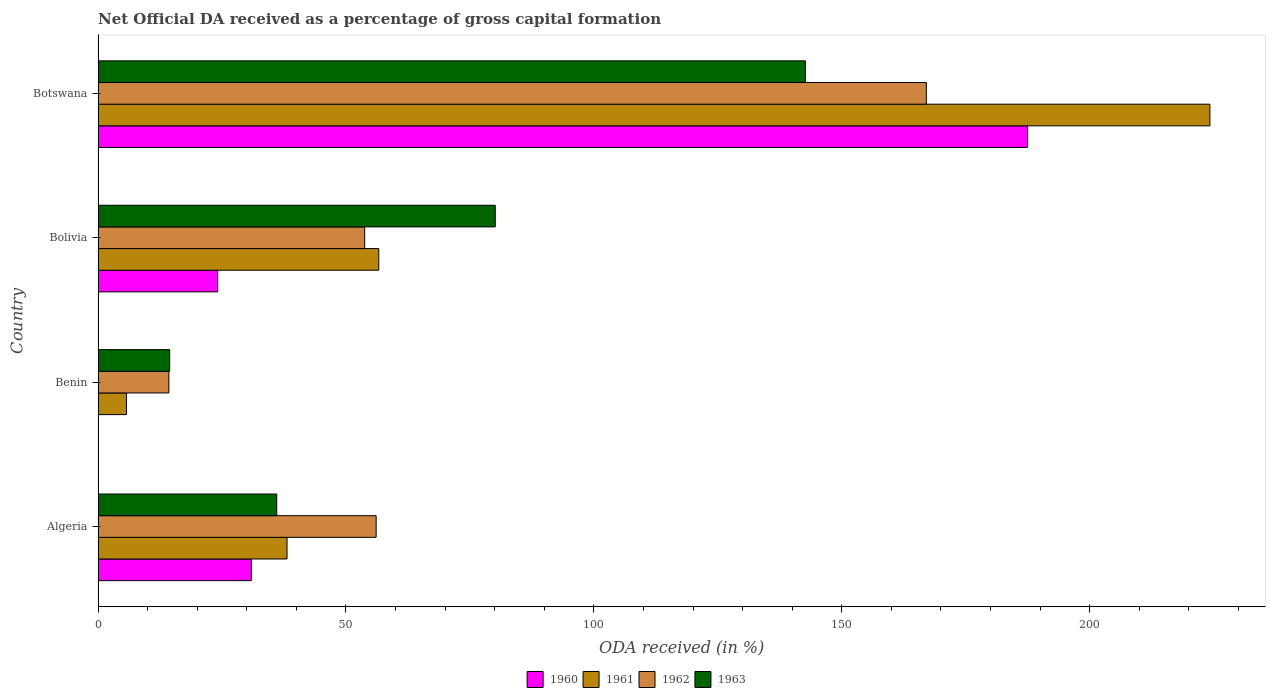How many different coloured bars are there?
Provide a short and direct response. 4. How many bars are there on the 2nd tick from the top?
Your response must be concise. 4. What is the label of the 3rd group of bars from the top?
Offer a very short reply. Benin. In how many cases, is the number of bars for a given country not equal to the number of legend labels?
Ensure brevity in your answer.  0. What is the net ODA received in 1963 in Botswana?
Your answer should be compact. 142.68. Across all countries, what is the maximum net ODA received in 1962?
Your answer should be compact. 167.07. Across all countries, what is the minimum net ODA received in 1963?
Give a very brief answer. 14.44. In which country was the net ODA received in 1961 maximum?
Offer a terse response. Botswana. In which country was the net ODA received in 1963 minimum?
Provide a succinct answer. Benin. What is the total net ODA received in 1961 in the graph?
Keep it short and to the point. 324.72. What is the difference between the net ODA received in 1960 in Benin and that in Bolivia?
Provide a succinct answer. -24.04. What is the difference between the net ODA received in 1962 in Botswana and the net ODA received in 1963 in Benin?
Provide a short and direct response. 152.63. What is the average net ODA received in 1962 per country?
Provide a short and direct response. 72.8. What is the difference between the net ODA received in 1962 and net ODA received in 1960 in Algeria?
Your answer should be very brief. 25.19. In how many countries, is the net ODA received in 1963 greater than 220 %?
Your answer should be very brief. 0. What is the ratio of the net ODA received in 1963 in Benin to that in Botswana?
Provide a short and direct response. 0.1. Is the net ODA received in 1962 in Benin less than that in Bolivia?
Ensure brevity in your answer.  Yes. Is the difference between the net ODA received in 1962 in Benin and Botswana greater than the difference between the net ODA received in 1960 in Benin and Botswana?
Offer a very short reply. Yes. What is the difference between the highest and the second highest net ODA received in 1963?
Give a very brief answer. 62.56. What is the difference between the highest and the lowest net ODA received in 1962?
Ensure brevity in your answer.  152.79. In how many countries, is the net ODA received in 1963 greater than the average net ODA received in 1963 taken over all countries?
Provide a succinct answer. 2. Is it the case that in every country, the sum of the net ODA received in 1960 and net ODA received in 1961 is greater than the sum of net ODA received in 1963 and net ODA received in 1962?
Your answer should be compact. No. What does the 3rd bar from the top in Botswana represents?
Ensure brevity in your answer.  1961. What does the 1st bar from the bottom in Botswana represents?
Your answer should be very brief. 1960. Is it the case that in every country, the sum of the net ODA received in 1963 and net ODA received in 1961 is greater than the net ODA received in 1962?
Your response must be concise. Yes. How many bars are there?
Give a very brief answer. 16. Are all the bars in the graph horizontal?
Offer a very short reply. Yes. How many countries are there in the graph?
Give a very brief answer. 4. Does the graph contain any zero values?
Make the answer very short. No. Where does the legend appear in the graph?
Give a very brief answer. Bottom center. How are the legend labels stacked?
Offer a very short reply. Horizontal. What is the title of the graph?
Offer a terse response. Net Official DA received as a percentage of gross capital formation. Does "1974" appear as one of the legend labels in the graph?
Your answer should be compact. No. What is the label or title of the X-axis?
Offer a very short reply. ODA received (in %). What is the label or title of the Y-axis?
Provide a short and direct response. Country. What is the ODA received (in %) in 1960 in Algeria?
Offer a terse response. 30.9. What is the ODA received (in %) of 1961 in Algeria?
Offer a terse response. 38.11. What is the ODA received (in %) of 1962 in Algeria?
Give a very brief answer. 56.09. What is the ODA received (in %) of 1963 in Algeria?
Offer a terse response. 36.04. What is the ODA received (in %) of 1960 in Benin?
Ensure brevity in your answer.  0.08. What is the ODA received (in %) of 1961 in Benin?
Give a very brief answer. 5.73. What is the ODA received (in %) of 1962 in Benin?
Provide a short and direct response. 14.28. What is the ODA received (in %) of 1963 in Benin?
Provide a short and direct response. 14.44. What is the ODA received (in %) in 1960 in Bolivia?
Ensure brevity in your answer.  24.12. What is the ODA received (in %) in 1961 in Bolivia?
Your response must be concise. 56.62. What is the ODA received (in %) in 1962 in Bolivia?
Keep it short and to the point. 53.77. What is the ODA received (in %) in 1963 in Bolivia?
Offer a terse response. 80.11. What is the ODA received (in %) in 1960 in Botswana?
Provide a short and direct response. 187.49. What is the ODA received (in %) of 1961 in Botswana?
Provide a short and direct response. 224.27. What is the ODA received (in %) in 1962 in Botswana?
Offer a very short reply. 167.07. What is the ODA received (in %) of 1963 in Botswana?
Ensure brevity in your answer.  142.68. Across all countries, what is the maximum ODA received (in %) in 1960?
Keep it short and to the point. 187.49. Across all countries, what is the maximum ODA received (in %) in 1961?
Keep it short and to the point. 224.27. Across all countries, what is the maximum ODA received (in %) of 1962?
Your response must be concise. 167.07. Across all countries, what is the maximum ODA received (in %) of 1963?
Give a very brief answer. 142.68. Across all countries, what is the minimum ODA received (in %) of 1960?
Your answer should be compact. 0.08. Across all countries, what is the minimum ODA received (in %) of 1961?
Offer a very short reply. 5.73. Across all countries, what is the minimum ODA received (in %) in 1962?
Offer a terse response. 14.28. Across all countries, what is the minimum ODA received (in %) in 1963?
Provide a succinct answer. 14.44. What is the total ODA received (in %) in 1960 in the graph?
Offer a terse response. 242.58. What is the total ODA received (in %) in 1961 in the graph?
Give a very brief answer. 324.72. What is the total ODA received (in %) of 1962 in the graph?
Provide a succinct answer. 291.21. What is the total ODA received (in %) in 1963 in the graph?
Your response must be concise. 273.27. What is the difference between the ODA received (in %) of 1960 in Algeria and that in Benin?
Your answer should be compact. 30.82. What is the difference between the ODA received (in %) in 1961 in Algeria and that in Benin?
Your response must be concise. 32.39. What is the difference between the ODA received (in %) in 1962 in Algeria and that in Benin?
Your response must be concise. 41.81. What is the difference between the ODA received (in %) of 1963 in Algeria and that in Benin?
Keep it short and to the point. 21.6. What is the difference between the ODA received (in %) of 1960 in Algeria and that in Bolivia?
Your response must be concise. 6.78. What is the difference between the ODA received (in %) of 1961 in Algeria and that in Bolivia?
Your response must be concise. -18.5. What is the difference between the ODA received (in %) of 1962 in Algeria and that in Bolivia?
Offer a terse response. 2.31. What is the difference between the ODA received (in %) of 1963 in Algeria and that in Bolivia?
Provide a short and direct response. -44.08. What is the difference between the ODA received (in %) of 1960 in Algeria and that in Botswana?
Ensure brevity in your answer.  -156.58. What is the difference between the ODA received (in %) in 1961 in Algeria and that in Botswana?
Provide a short and direct response. -186.15. What is the difference between the ODA received (in %) of 1962 in Algeria and that in Botswana?
Your answer should be compact. -110.98. What is the difference between the ODA received (in %) in 1963 in Algeria and that in Botswana?
Your answer should be very brief. -106.64. What is the difference between the ODA received (in %) of 1960 in Benin and that in Bolivia?
Offer a terse response. -24.04. What is the difference between the ODA received (in %) of 1961 in Benin and that in Bolivia?
Provide a short and direct response. -50.89. What is the difference between the ODA received (in %) of 1962 in Benin and that in Bolivia?
Your response must be concise. -39.5. What is the difference between the ODA received (in %) of 1963 in Benin and that in Bolivia?
Your response must be concise. -65.67. What is the difference between the ODA received (in %) in 1960 in Benin and that in Botswana?
Give a very brief answer. -187.41. What is the difference between the ODA received (in %) of 1961 in Benin and that in Botswana?
Your response must be concise. -218.54. What is the difference between the ODA received (in %) of 1962 in Benin and that in Botswana?
Your answer should be compact. -152.79. What is the difference between the ODA received (in %) of 1963 in Benin and that in Botswana?
Provide a short and direct response. -128.24. What is the difference between the ODA received (in %) in 1960 in Bolivia and that in Botswana?
Offer a very short reply. -163.37. What is the difference between the ODA received (in %) of 1961 in Bolivia and that in Botswana?
Ensure brevity in your answer.  -167.65. What is the difference between the ODA received (in %) in 1962 in Bolivia and that in Botswana?
Make the answer very short. -113.3. What is the difference between the ODA received (in %) of 1963 in Bolivia and that in Botswana?
Offer a terse response. -62.56. What is the difference between the ODA received (in %) in 1960 in Algeria and the ODA received (in %) in 1961 in Benin?
Your response must be concise. 25.17. What is the difference between the ODA received (in %) of 1960 in Algeria and the ODA received (in %) of 1962 in Benin?
Your response must be concise. 16.62. What is the difference between the ODA received (in %) of 1960 in Algeria and the ODA received (in %) of 1963 in Benin?
Your response must be concise. 16.46. What is the difference between the ODA received (in %) in 1961 in Algeria and the ODA received (in %) in 1962 in Benin?
Your answer should be very brief. 23.84. What is the difference between the ODA received (in %) of 1961 in Algeria and the ODA received (in %) of 1963 in Benin?
Offer a very short reply. 23.67. What is the difference between the ODA received (in %) in 1962 in Algeria and the ODA received (in %) in 1963 in Benin?
Ensure brevity in your answer.  41.65. What is the difference between the ODA received (in %) of 1960 in Algeria and the ODA received (in %) of 1961 in Bolivia?
Keep it short and to the point. -25.71. What is the difference between the ODA received (in %) in 1960 in Algeria and the ODA received (in %) in 1962 in Bolivia?
Make the answer very short. -22.87. What is the difference between the ODA received (in %) of 1960 in Algeria and the ODA received (in %) of 1963 in Bolivia?
Your answer should be compact. -49.21. What is the difference between the ODA received (in %) of 1961 in Algeria and the ODA received (in %) of 1962 in Bolivia?
Provide a short and direct response. -15.66. What is the difference between the ODA received (in %) in 1961 in Algeria and the ODA received (in %) in 1963 in Bolivia?
Keep it short and to the point. -42. What is the difference between the ODA received (in %) of 1962 in Algeria and the ODA received (in %) of 1963 in Bolivia?
Your answer should be very brief. -24.03. What is the difference between the ODA received (in %) of 1960 in Algeria and the ODA received (in %) of 1961 in Botswana?
Offer a very short reply. -193.36. What is the difference between the ODA received (in %) of 1960 in Algeria and the ODA received (in %) of 1962 in Botswana?
Give a very brief answer. -136.17. What is the difference between the ODA received (in %) in 1960 in Algeria and the ODA received (in %) in 1963 in Botswana?
Offer a terse response. -111.78. What is the difference between the ODA received (in %) of 1961 in Algeria and the ODA received (in %) of 1962 in Botswana?
Give a very brief answer. -128.96. What is the difference between the ODA received (in %) in 1961 in Algeria and the ODA received (in %) in 1963 in Botswana?
Offer a very short reply. -104.56. What is the difference between the ODA received (in %) in 1962 in Algeria and the ODA received (in %) in 1963 in Botswana?
Ensure brevity in your answer.  -86.59. What is the difference between the ODA received (in %) of 1960 in Benin and the ODA received (in %) of 1961 in Bolivia?
Offer a very short reply. -56.54. What is the difference between the ODA received (in %) in 1960 in Benin and the ODA received (in %) in 1962 in Bolivia?
Ensure brevity in your answer.  -53.7. What is the difference between the ODA received (in %) in 1960 in Benin and the ODA received (in %) in 1963 in Bolivia?
Your answer should be compact. -80.04. What is the difference between the ODA received (in %) in 1961 in Benin and the ODA received (in %) in 1962 in Bolivia?
Ensure brevity in your answer.  -48.05. What is the difference between the ODA received (in %) in 1961 in Benin and the ODA received (in %) in 1963 in Bolivia?
Your answer should be very brief. -74.39. What is the difference between the ODA received (in %) in 1962 in Benin and the ODA received (in %) in 1963 in Bolivia?
Provide a succinct answer. -65.84. What is the difference between the ODA received (in %) of 1960 in Benin and the ODA received (in %) of 1961 in Botswana?
Offer a very short reply. -224.19. What is the difference between the ODA received (in %) in 1960 in Benin and the ODA received (in %) in 1962 in Botswana?
Make the answer very short. -166.99. What is the difference between the ODA received (in %) in 1960 in Benin and the ODA received (in %) in 1963 in Botswana?
Ensure brevity in your answer.  -142.6. What is the difference between the ODA received (in %) in 1961 in Benin and the ODA received (in %) in 1962 in Botswana?
Your answer should be compact. -161.34. What is the difference between the ODA received (in %) in 1961 in Benin and the ODA received (in %) in 1963 in Botswana?
Keep it short and to the point. -136.95. What is the difference between the ODA received (in %) of 1962 in Benin and the ODA received (in %) of 1963 in Botswana?
Provide a succinct answer. -128.4. What is the difference between the ODA received (in %) in 1960 in Bolivia and the ODA received (in %) in 1961 in Botswana?
Your answer should be compact. -200.15. What is the difference between the ODA received (in %) in 1960 in Bolivia and the ODA received (in %) in 1962 in Botswana?
Give a very brief answer. -142.95. What is the difference between the ODA received (in %) of 1960 in Bolivia and the ODA received (in %) of 1963 in Botswana?
Your answer should be compact. -118.56. What is the difference between the ODA received (in %) of 1961 in Bolivia and the ODA received (in %) of 1962 in Botswana?
Offer a terse response. -110.45. What is the difference between the ODA received (in %) in 1961 in Bolivia and the ODA received (in %) in 1963 in Botswana?
Give a very brief answer. -86.06. What is the difference between the ODA received (in %) in 1962 in Bolivia and the ODA received (in %) in 1963 in Botswana?
Offer a very short reply. -88.9. What is the average ODA received (in %) of 1960 per country?
Provide a succinct answer. 60.65. What is the average ODA received (in %) of 1961 per country?
Ensure brevity in your answer.  81.18. What is the average ODA received (in %) of 1962 per country?
Ensure brevity in your answer.  72.8. What is the average ODA received (in %) in 1963 per country?
Provide a succinct answer. 68.32. What is the difference between the ODA received (in %) in 1960 and ODA received (in %) in 1961 in Algeria?
Offer a terse response. -7.21. What is the difference between the ODA received (in %) of 1960 and ODA received (in %) of 1962 in Algeria?
Keep it short and to the point. -25.19. What is the difference between the ODA received (in %) of 1960 and ODA received (in %) of 1963 in Algeria?
Give a very brief answer. -5.14. What is the difference between the ODA received (in %) of 1961 and ODA received (in %) of 1962 in Algeria?
Give a very brief answer. -17.98. What is the difference between the ODA received (in %) of 1961 and ODA received (in %) of 1963 in Algeria?
Ensure brevity in your answer.  2.08. What is the difference between the ODA received (in %) in 1962 and ODA received (in %) in 1963 in Algeria?
Your answer should be compact. 20.05. What is the difference between the ODA received (in %) of 1960 and ODA received (in %) of 1961 in Benin?
Make the answer very short. -5.65. What is the difference between the ODA received (in %) in 1960 and ODA received (in %) in 1962 in Benin?
Provide a short and direct response. -14.2. What is the difference between the ODA received (in %) in 1960 and ODA received (in %) in 1963 in Benin?
Your response must be concise. -14.36. What is the difference between the ODA received (in %) of 1961 and ODA received (in %) of 1962 in Benin?
Provide a succinct answer. -8.55. What is the difference between the ODA received (in %) in 1961 and ODA received (in %) in 1963 in Benin?
Give a very brief answer. -8.71. What is the difference between the ODA received (in %) in 1962 and ODA received (in %) in 1963 in Benin?
Keep it short and to the point. -0.16. What is the difference between the ODA received (in %) of 1960 and ODA received (in %) of 1961 in Bolivia?
Provide a succinct answer. -32.5. What is the difference between the ODA received (in %) of 1960 and ODA received (in %) of 1962 in Bolivia?
Give a very brief answer. -29.66. What is the difference between the ODA received (in %) of 1960 and ODA received (in %) of 1963 in Bolivia?
Your answer should be very brief. -56. What is the difference between the ODA received (in %) in 1961 and ODA received (in %) in 1962 in Bolivia?
Your response must be concise. 2.84. What is the difference between the ODA received (in %) of 1961 and ODA received (in %) of 1963 in Bolivia?
Offer a very short reply. -23.5. What is the difference between the ODA received (in %) of 1962 and ODA received (in %) of 1963 in Bolivia?
Offer a very short reply. -26.34. What is the difference between the ODA received (in %) of 1960 and ODA received (in %) of 1961 in Botswana?
Your response must be concise. -36.78. What is the difference between the ODA received (in %) of 1960 and ODA received (in %) of 1962 in Botswana?
Keep it short and to the point. 20.42. What is the difference between the ODA received (in %) of 1960 and ODA received (in %) of 1963 in Botswana?
Provide a short and direct response. 44.81. What is the difference between the ODA received (in %) in 1961 and ODA received (in %) in 1962 in Botswana?
Offer a terse response. 57.2. What is the difference between the ODA received (in %) in 1961 and ODA received (in %) in 1963 in Botswana?
Provide a short and direct response. 81.59. What is the difference between the ODA received (in %) in 1962 and ODA received (in %) in 1963 in Botswana?
Ensure brevity in your answer.  24.39. What is the ratio of the ODA received (in %) in 1960 in Algeria to that in Benin?
Offer a terse response. 399.3. What is the ratio of the ODA received (in %) of 1961 in Algeria to that in Benin?
Provide a succinct answer. 6.65. What is the ratio of the ODA received (in %) in 1962 in Algeria to that in Benin?
Your answer should be very brief. 3.93. What is the ratio of the ODA received (in %) in 1963 in Algeria to that in Benin?
Offer a terse response. 2.5. What is the ratio of the ODA received (in %) of 1960 in Algeria to that in Bolivia?
Make the answer very short. 1.28. What is the ratio of the ODA received (in %) of 1961 in Algeria to that in Bolivia?
Ensure brevity in your answer.  0.67. What is the ratio of the ODA received (in %) in 1962 in Algeria to that in Bolivia?
Give a very brief answer. 1.04. What is the ratio of the ODA received (in %) of 1963 in Algeria to that in Bolivia?
Your response must be concise. 0.45. What is the ratio of the ODA received (in %) of 1960 in Algeria to that in Botswana?
Keep it short and to the point. 0.16. What is the ratio of the ODA received (in %) of 1961 in Algeria to that in Botswana?
Your answer should be compact. 0.17. What is the ratio of the ODA received (in %) of 1962 in Algeria to that in Botswana?
Your response must be concise. 0.34. What is the ratio of the ODA received (in %) of 1963 in Algeria to that in Botswana?
Your answer should be very brief. 0.25. What is the ratio of the ODA received (in %) in 1960 in Benin to that in Bolivia?
Your answer should be very brief. 0. What is the ratio of the ODA received (in %) in 1961 in Benin to that in Bolivia?
Your answer should be very brief. 0.1. What is the ratio of the ODA received (in %) of 1962 in Benin to that in Bolivia?
Keep it short and to the point. 0.27. What is the ratio of the ODA received (in %) of 1963 in Benin to that in Bolivia?
Provide a succinct answer. 0.18. What is the ratio of the ODA received (in %) of 1960 in Benin to that in Botswana?
Your answer should be compact. 0. What is the ratio of the ODA received (in %) of 1961 in Benin to that in Botswana?
Offer a very short reply. 0.03. What is the ratio of the ODA received (in %) of 1962 in Benin to that in Botswana?
Your answer should be very brief. 0.09. What is the ratio of the ODA received (in %) of 1963 in Benin to that in Botswana?
Your response must be concise. 0.1. What is the ratio of the ODA received (in %) in 1960 in Bolivia to that in Botswana?
Make the answer very short. 0.13. What is the ratio of the ODA received (in %) of 1961 in Bolivia to that in Botswana?
Make the answer very short. 0.25. What is the ratio of the ODA received (in %) in 1962 in Bolivia to that in Botswana?
Provide a short and direct response. 0.32. What is the ratio of the ODA received (in %) of 1963 in Bolivia to that in Botswana?
Ensure brevity in your answer.  0.56. What is the difference between the highest and the second highest ODA received (in %) in 1960?
Your answer should be very brief. 156.58. What is the difference between the highest and the second highest ODA received (in %) of 1961?
Your response must be concise. 167.65. What is the difference between the highest and the second highest ODA received (in %) of 1962?
Keep it short and to the point. 110.98. What is the difference between the highest and the second highest ODA received (in %) of 1963?
Give a very brief answer. 62.56. What is the difference between the highest and the lowest ODA received (in %) of 1960?
Your answer should be very brief. 187.41. What is the difference between the highest and the lowest ODA received (in %) of 1961?
Your answer should be compact. 218.54. What is the difference between the highest and the lowest ODA received (in %) of 1962?
Offer a very short reply. 152.79. What is the difference between the highest and the lowest ODA received (in %) in 1963?
Give a very brief answer. 128.24. 